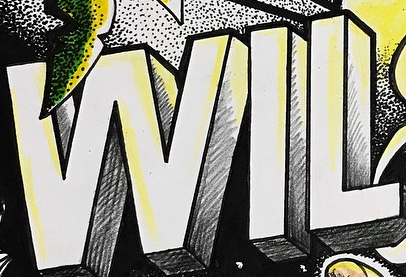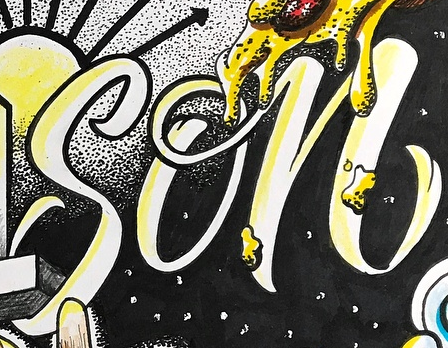Identify the words shown in these images in order, separated by a semicolon. WIL; son 